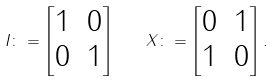Convert formula to latex. <formula><loc_0><loc_0><loc_500><loc_500>I \colon = \begin{bmatrix} 1 & 0 \\ 0 & 1 \end{bmatrix} \quad X \colon = \begin{bmatrix} 0 & 1 \\ 1 & 0 \end{bmatrix} .</formula> 